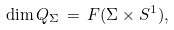<formula> <loc_0><loc_0><loc_500><loc_500>\dim Q _ { \Sigma } \, = \, F ( \Sigma \times S ^ { 1 } ) ,</formula> 